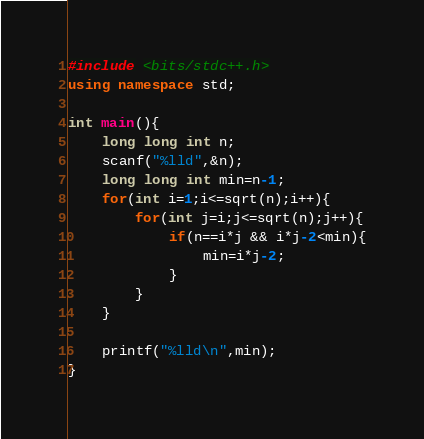<code> <loc_0><loc_0><loc_500><loc_500><_C++_>#include <bits/stdc++.h>
using namespace std;

int main(){
    long long int n;
    scanf("%lld",&n);
    long long int min=n-1;
    for(int i=1;i<=sqrt(n);i++){
        for(int j=i;j<=sqrt(n);j++){
            if(n==i*j && i*j-2<min){
                min=i*j-2;
            }
        }
    }

    printf("%lld\n",min);
}</code> 